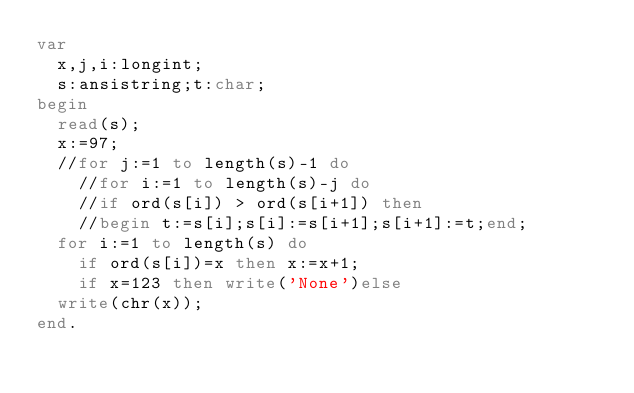Convert code to text. <code><loc_0><loc_0><loc_500><loc_500><_Pascal_>var
  x,j,i:longint;
  s:ansistring;t:char;
begin
  read(s);
  x:=97;
  //for j:=1 to length(s)-1 do
    //for i:=1 to length(s)-j do
    //if ord(s[i]) > ord(s[i+1]) then
    //begin t:=s[i];s[i]:=s[i+1];s[i+1]:=t;end;
  for i:=1 to length(s) do
    if ord(s[i])=x then x:=x+1;
    if x=123 then write('None')else
  write(chr(x));
end.</code> 